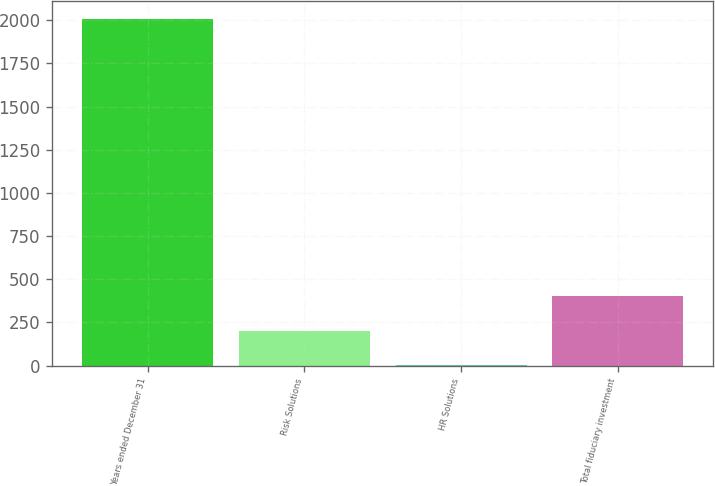Convert chart to OTSL. <chart><loc_0><loc_0><loc_500><loc_500><bar_chart><fcel>Years ended December 31<fcel>Risk Solutions<fcel>HR Solutions<fcel>Total fiduciary investment<nl><fcel>2008<fcel>203.5<fcel>3<fcel>404<nl></chart> 